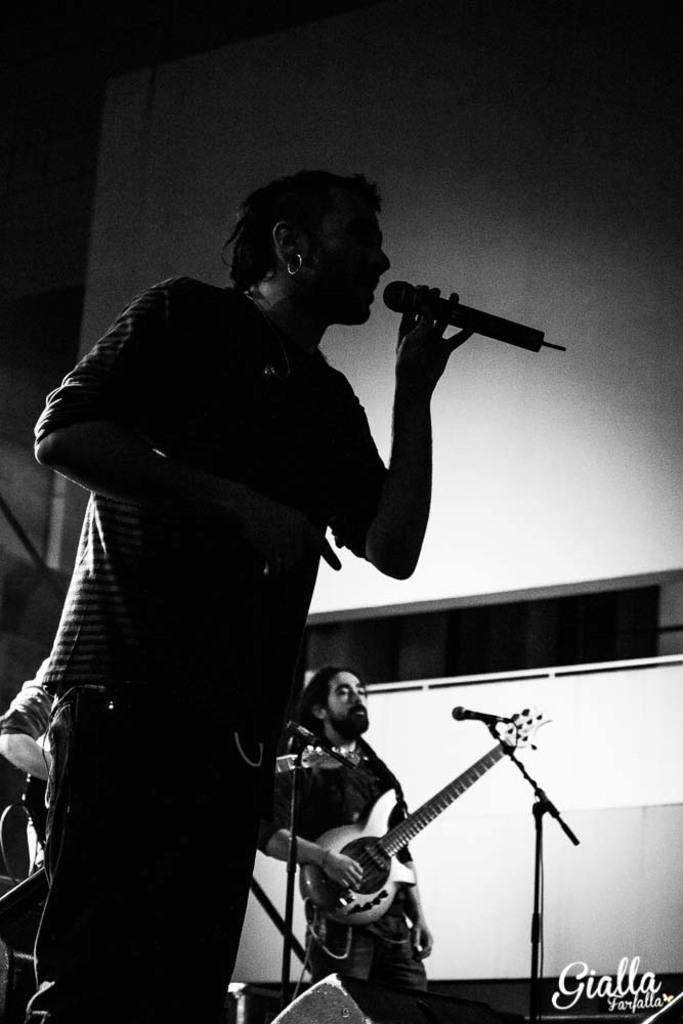What is the person in the image holding? The person is holding a microphone in the image. What is the person with the microphone doing? The person is singing. What is the other person in the image doing? The other person is playing a guitar. What can be seen in the background of the image? There is a wall visible in the image. What time does the father read the news in the image? There is no father or news reading depicted in the image. 